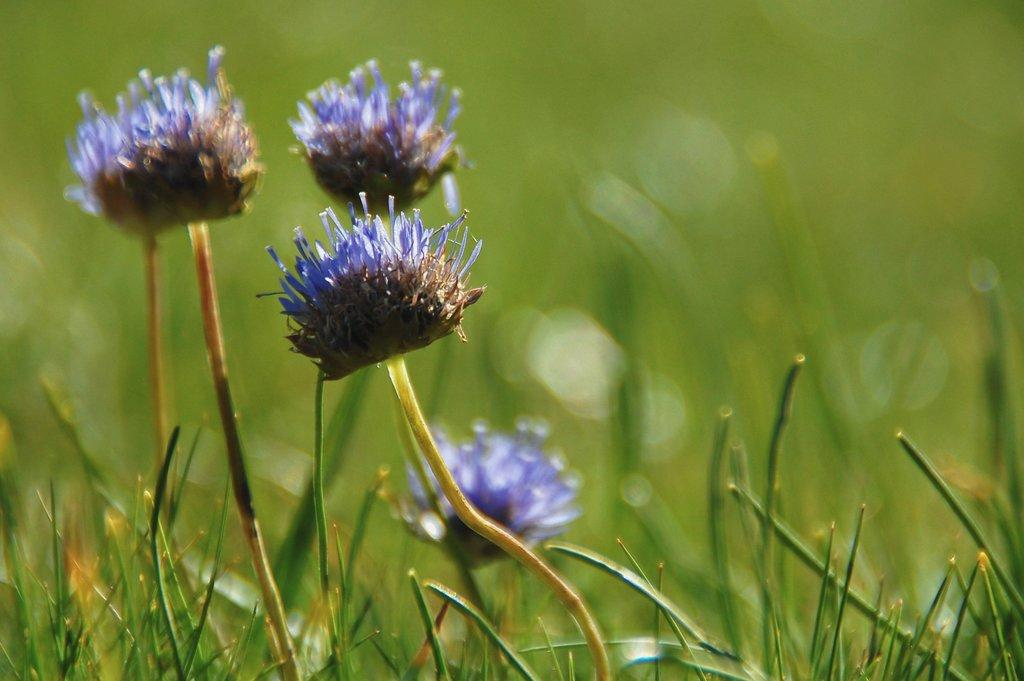What type of plants can be seen in the image? There are flowers in the image. What colors are the flowers? The flowers have purple and brown colors. What color is the background of the image? The background of the image is green. What type of crack can be seen in the image? There is no crack present in the image; it features flowers with purple and brown colors against a green background. 